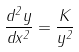<formula> <loc_0><loc_0><loc_500><loc_500>\frac { d ^ { 2 } y } { d x ^ { 2 } } = \frac { K } { y ^ { 2 } }</formula> 